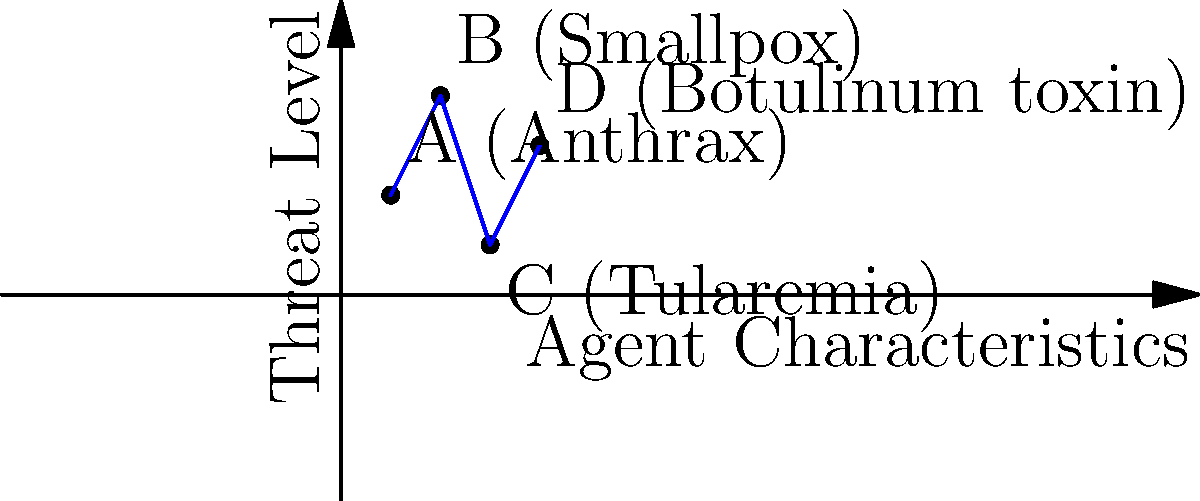Based on the graph showing the relationship between agent characteristics and threat level for potential bioterrorism agents, which agent poses the highest threat and why might this be significant for national security policy? To answer this question, we need to analyze the graph and interpret its implications for national security policy. Let's break it down step-by-step:

1. Interpret the graph:
   - The x-axis represents "Agent Characteristics"
   - The y-axis represents "Threat Level"
   - Higher y-values indicate a higher threat level

2. Identify the agents:
   A: Anthrax
   B: Smallpox
   C: Tularemia
   D: Botulinum toxin

3. Compare the threat levels:
   - Anthrax (A): y ≈ 2
   - Smallpox (B): y ≈ 4
   - Tularemia (C): y ≈ 1
   - Botulinum toxin (D): y ≈ 3

4. Determine the highest threat:
   Smallpox (B) has the highest y-value, indicating the highest threat level.

5. Consider the significance for national security policy:
   - Smallpox's high threat level may be due to its contagiousness, potential for rapid spread, and lack of widespread immunity in the population.
   - This high threat level suggests that national security policies should prioritize:
     a) Stockpiling smallpox vaccines
     b) Enhancing early detection systems
     c) Developing response protocols for potential smallpox outbreaks
     d) International cooperation to prevent access to smallpox samples

The identification of smallpox as the highest threat agent informs policymakers about resource allocation, preparedness efforts, and international collaboration priorities in bioterrorism prevention and response strategies.
Answer: Smallpox; highest threat level informs policy priorities for prevention, preparedness, and response. 